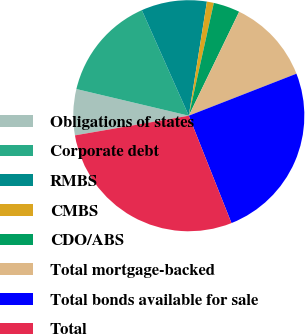Convert chart. <chart><loc_0><loc_0><loc_500><loc_500><pie_chart><fcel>Obligations of states<fcel>Corporate debt<fcel>RMBS<fcel>CMBS<fcel>CDO/ABS<fcel>Total mortgage-backed<fcel>Total bonds available for sale<fcel>Total<nl><fcel>6.43%<fcel>14.63%<fcel>9.17%<fcel>0.97%<fcel>3.7%<fcel>11.9%<fcel>24.9%<fcel>28.3%<nl></chart> 